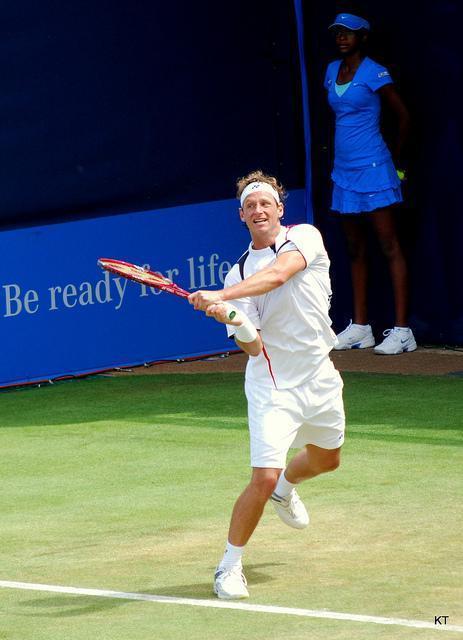How many people are there?
Give a very brief answer. 2. 